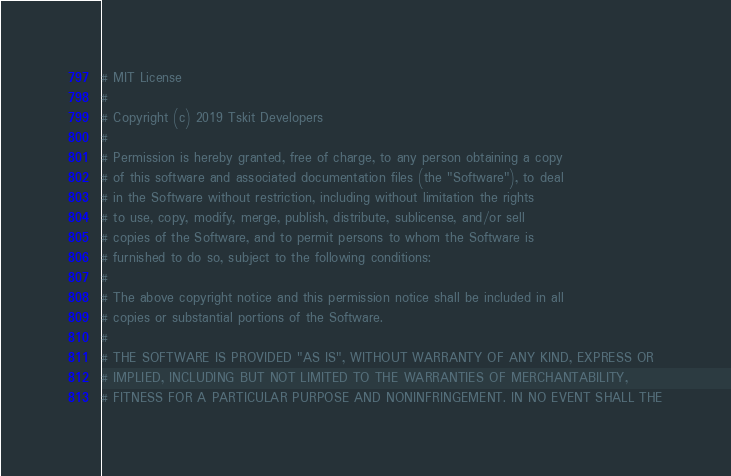Convert code to text. <code><loc_0><loc_0><loc_500><loc_500><_Python_># MIT License
#
# Copyright (c) 2019 Tskit Developers
#
# Permission is hereby granted, free of charge, to any person obtaining a copy
# of this software and associated documentation files (the "Software"), to deal
# in the Software without restriction, including without limitation the rights
# to use, copy, modify, merge, publish, distribute, sublicense, and/or sell
# copies of the Software, and to permit persons to whom the Software is
# furnished to do so, subject to the following conditions:
#
# The above copyright notice and this permission notice shall be included in all
# copies or substantial portions of the Software.
#
# THE SOFTWARE IS PROVIDED "AS IS", WITHOUT WARRANTY OF ANY KIND, EXPRESS OR
# IMPLIED, INCLUDING BUT NOT LIMITED TO THE WARRANTIES OF MERCHANTABILITY,
# FITNESS FOR A PARTICULAR PURPOSE AND NONINFRINGEMENT. IN NO EVENT SHALL THE</code> 